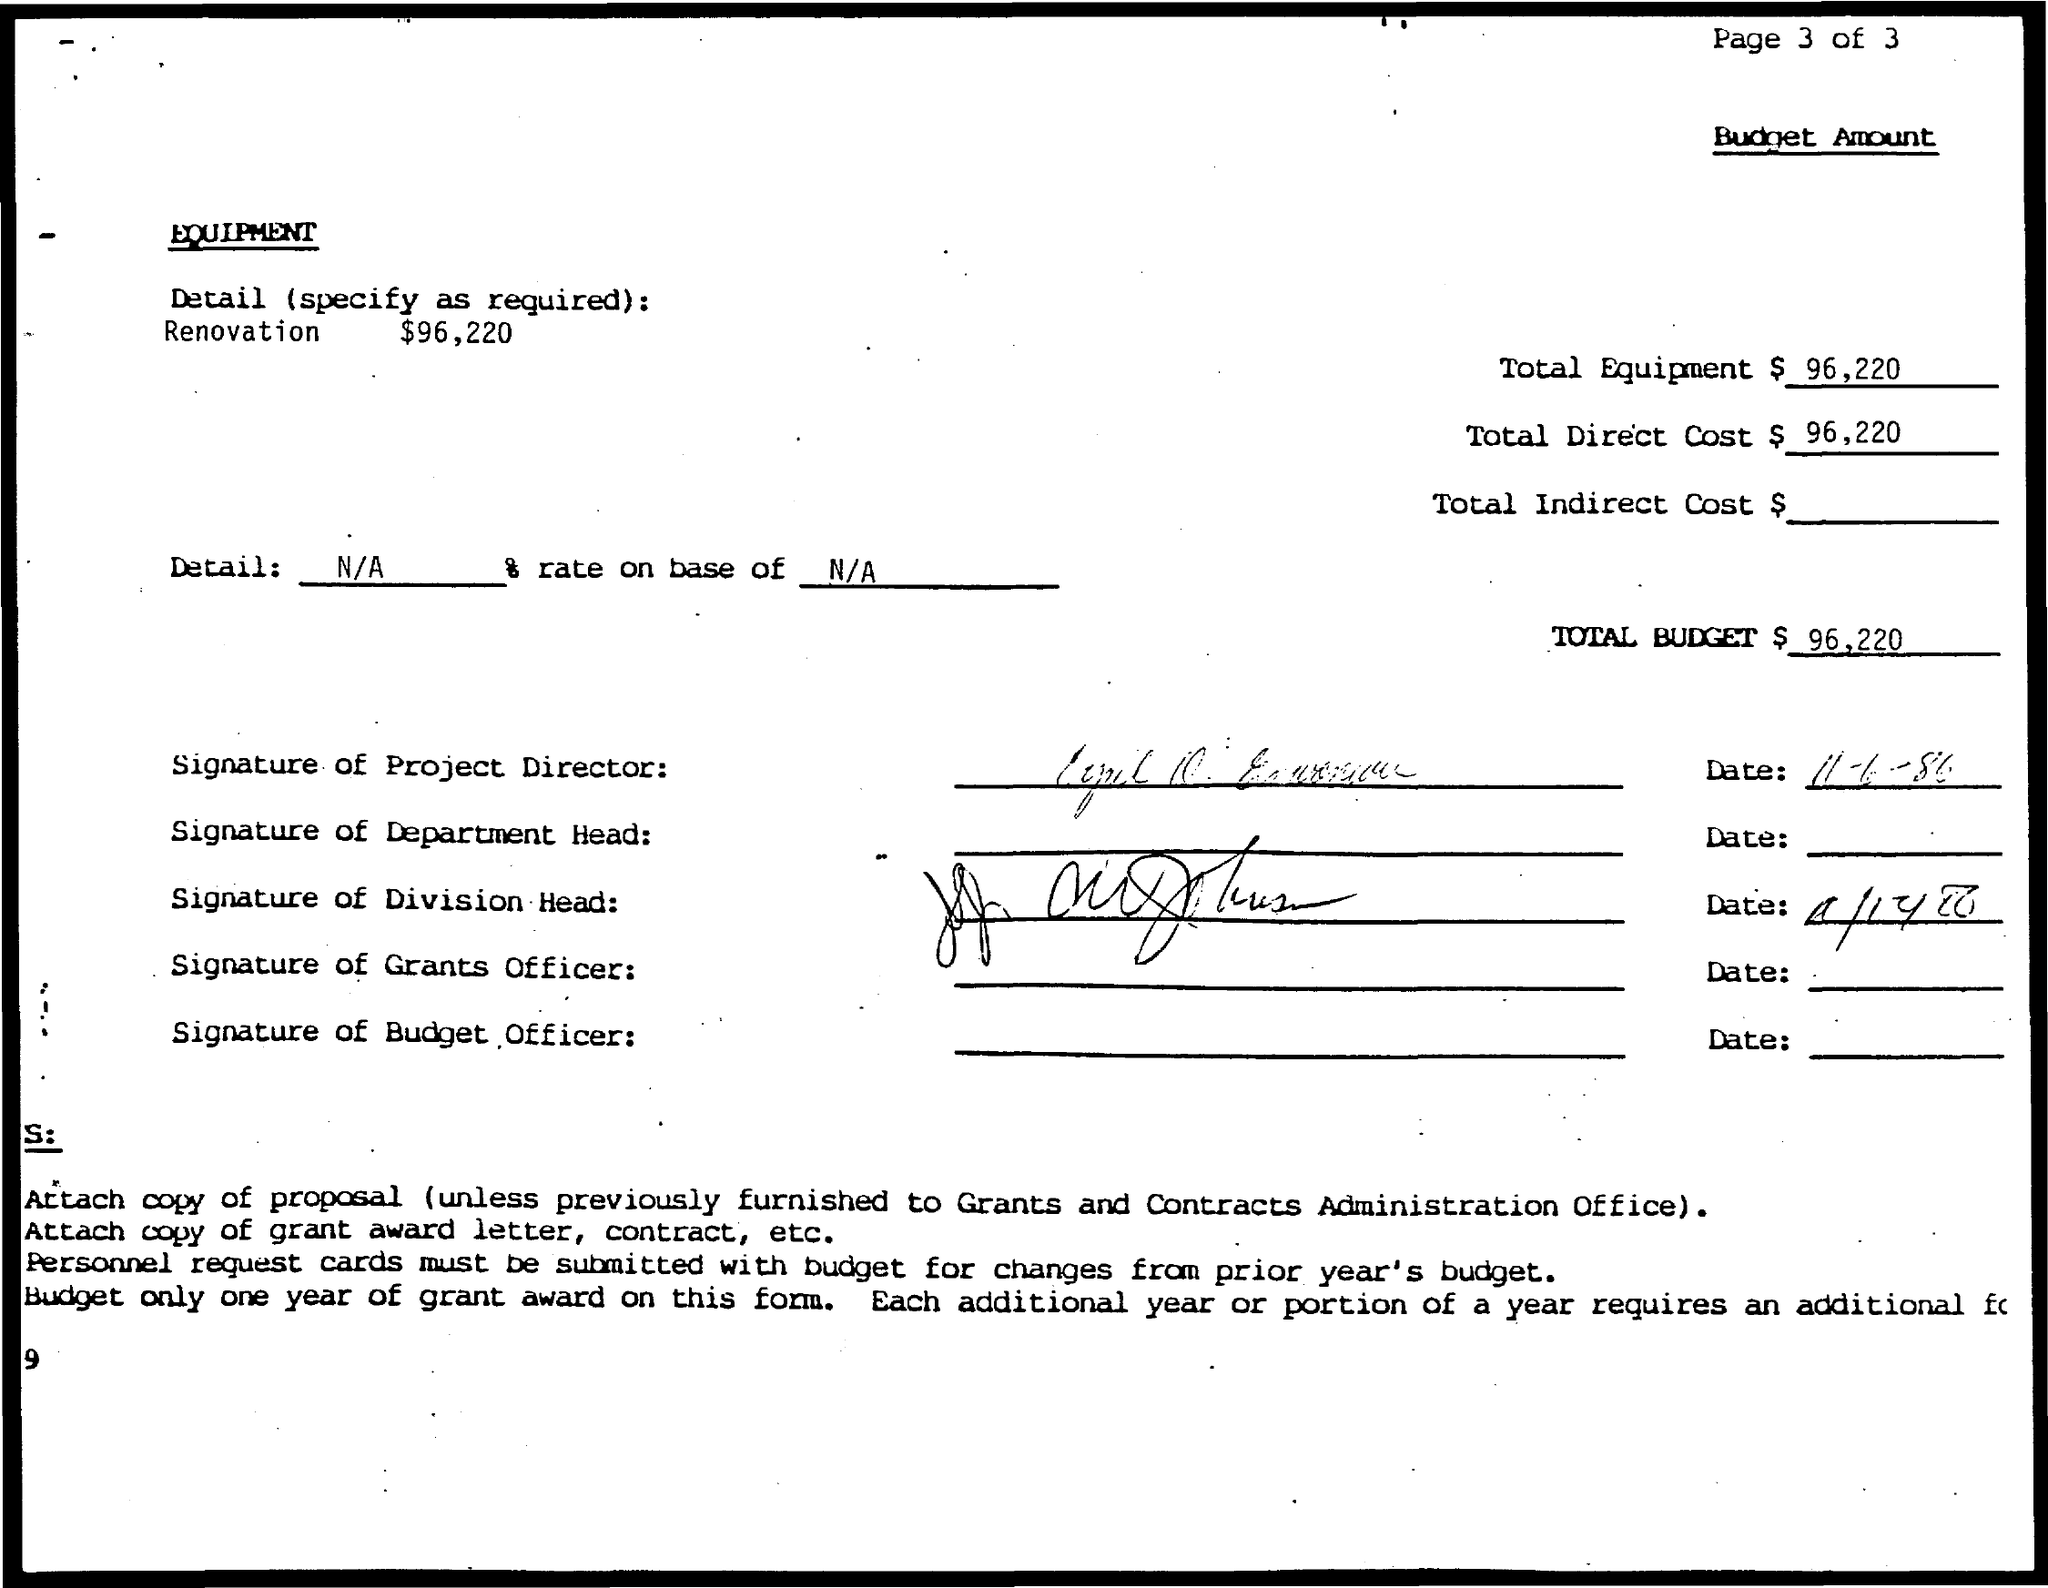What is the total budget?
Offer a very short reply. $ 96,220. Who has done first signature?
Offer a very short reply. PROJECT DIRECTOR. 